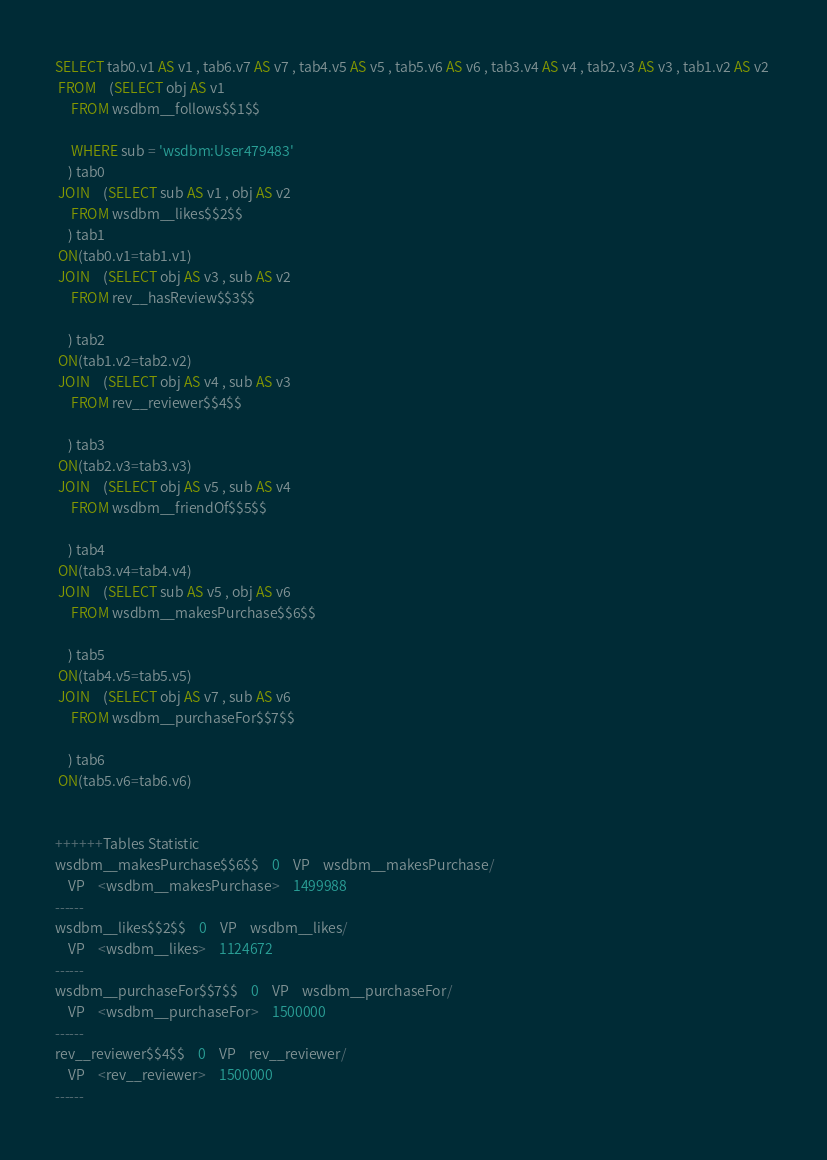Convert code to text. <code><loc_0><loc_0><loc_500><loc_500><_SQL_>SELECT tab0.v1 AS v1 , tab6.v7 AS v7 , tab4.v5 AS v5 , tab5.v6 AS v6 , tab3.v4 AS v4 , tab2.v3 AS v3 , tab1.v2 AS v2 
 FROM    (SELECT obj AS v1 
	 FROM wsdbm__follows$$1$$
	 
	 WHERE sub = 'wsdbm:User479483'
	) tab0
 JOIN    (SELECT sub AS v1 , obj AS v2 
	 FROM wsdbm__likes$$2$$
	) tab1
 ON(tab0.v1=tab1.v1)
 JOIN    (SELECT obj AS v3 , sub AS v2 
	 FROM rev__hasReview$$3$$
	
	) tab2
 ON(tab1.v2=tab2.v2)
 JOIN    (SELECT obj AS v4 , sub AS v3 
	 FROM rev__reviewer$$4$$
	
	) tab3
 ON(tab2.v3=tab3.v3)
 JOIN    (SELECT obj AS v5 , sub AS v4 
	 FROM wsdbm__friendOf$$5$$
	
	) tab4
 ON(tab3.v4=tab4.v4)
 JOIN    (SELECT sub AS v5 , obj AS v6 
	 FROM wsdbm__makesPurchase$$6$$
	
	) tab5
 ON(tab4.v5=tab5.v5)
 JOIN    (SELECT obj AS v7 , sub AS v6 
	 FROM wsdbm__purchaseFor$$7$$
	
	) tab6
 ON(tab5.v6=tab6.v6)


++++++Tables Statistic
wsdbm__makesPurchase$$6$$	0	VP	wsdbm__makesPurchase/
	VP	<wsdbm__makesPurchase>	1499988
------
wsdbm__likes$$2$$	0	VP	wsdbm__likes/
	VP	<wsdbm__likes>	1124672
------
wsdbm__purchaseFor$$7$$	0	VP	wsdbm__purchaseFor/
	VP	<wsdbm__purchaseFor>	1500000
------
rev__reviewer$$4$$	0	VP	rev__reviewer/
	VP	<rev__reviewer>	1500000
------</code> 